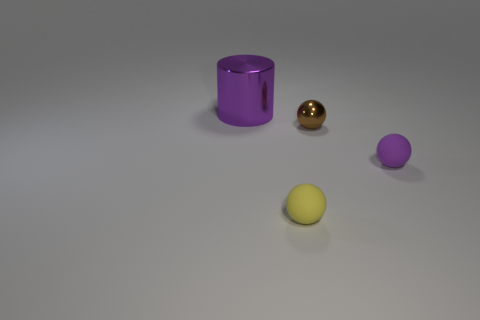Is there anything else that has the same size as the cylinder?
Your response must be concise. No. Is the number of small metal balls greater than the number of purple cubes?
Your answer should be very brief. Yes. How many large yellow cylinders are there?
Your answer should be compact. 0. There is a purple thing that is to the left of the rubber thing that is on the left side of the small matte sphere that is behind the yellow matte sphere; what is its shape?
Keep it short and to the point. Cylinder. Is the number of purple metallic objects on the left side of the yellow object less than the number of brown objects that are behind the large purple thing?
Your answer should be very brief. No. Do the purple object on the right side of the brown thing and the small thing to the left of the small brown object have the same shape?
Offer a terse response. Yes. There is a tiny rubber thing that is right of the tiny sphere in front of the small purple matte ball; what shape is it?
Ensure brevity in your answer.  Sphere. There is a matte sphere that is the same color as the big metal cylinder; what size is it?
Offer a very short reply. Small. Are there any tiny objects that have the same material as the large purple object?
Offer a terse response. Yes. What is the material of the tiny thing that is to the right of the small brown shiny sphere?
Your answer should be compact. Rubber. 